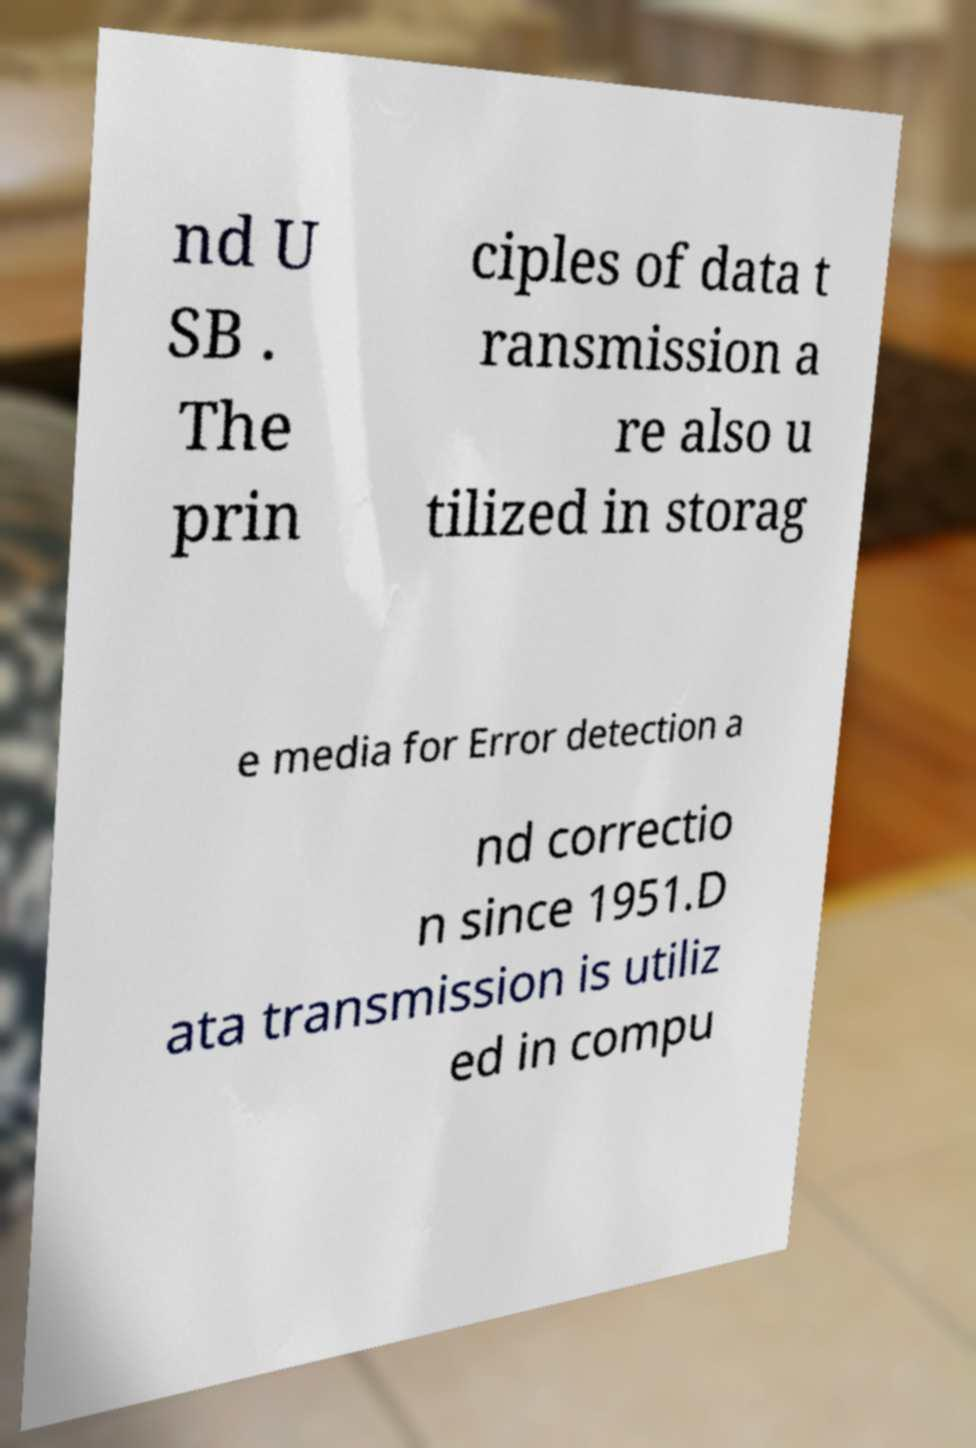I need the written content from this picture converted into text. Can you do that? nd U SB . The prin ciples of data t ransmission a re also u tilized in storag e media for Error detection a nd correctio n since 1951.D ata transmission is utiliz ed in compu 